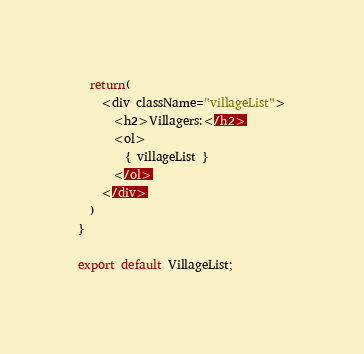Convert code to text. <code><loc_0><loc_0><loc_500><loc_500><_JavaScript_>
  return(
    <div className="villageList">
      <h2>Villagers:</h2>
      <ol>
        { villageList }
      </ol>
    </div>
  )
}

export default VillageList;
</code> 